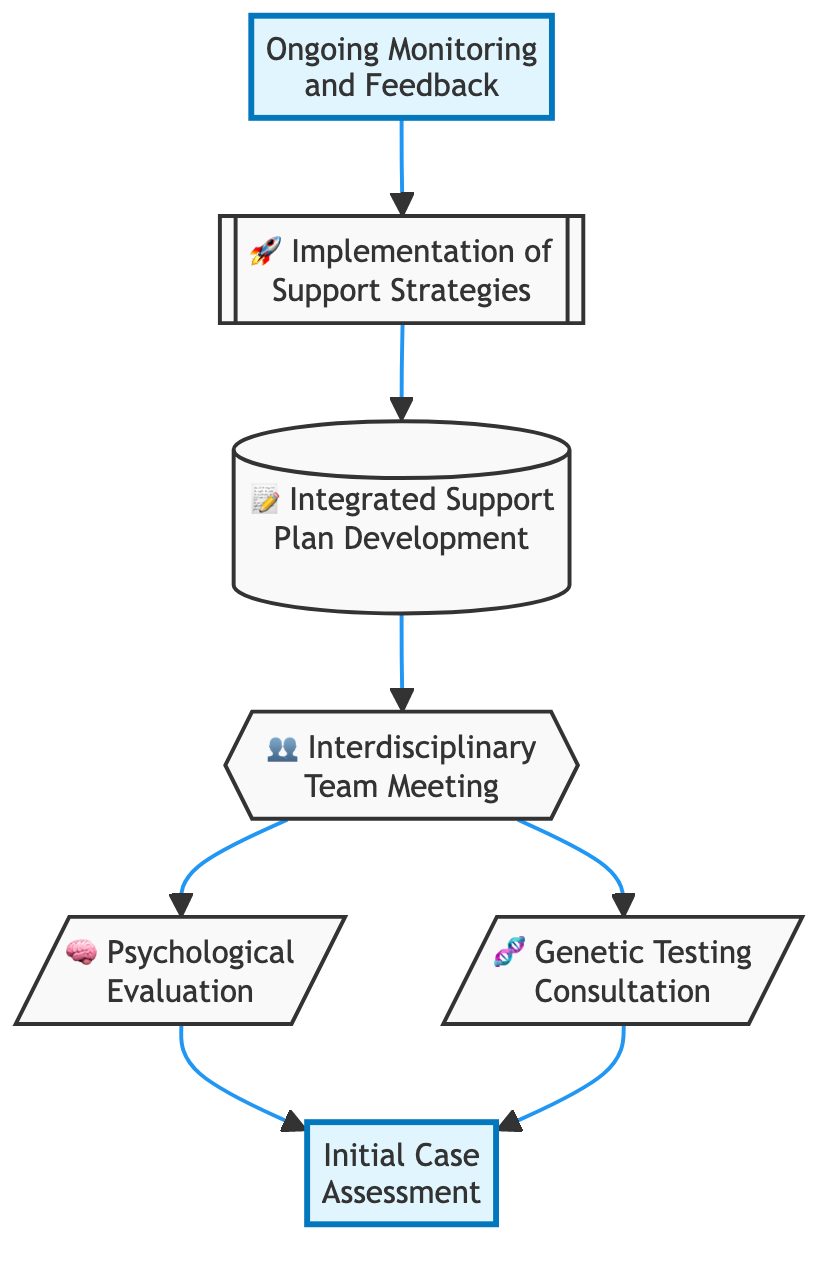What is the first step in the flow chart? The flow chart starts with the node labeled "Initial Case Assessment", which indicates it is the first step in the process of collaborative discussions between psychologists and geneticists.
Answer: Initial Case Assessment How many nodes are present in the diagram? By counting the individual elements in the flow chart, there are a total of seven nodes, each representing a different step in the collaborative framework.
Answer: 7 What is the final step in the flow chart? The last node in the diagram is titled "Ongoing Monitoring and Feedback", which concludes the series of steps outlined in the flow chart.
Answer: Ongoing Monitoring and Feedback What two assessments lead to the interdisciplinary team meeting? The processes "Psychological Evaluation" and "Genetic Testing Consultation" both direct to the "Interdisciplinary Team Meeting", indicating that insights from these assessments are shared in the meeting.
Answer: Psychological Evaluation and Genetic Testing Consultation Which step follows "Integrated Support Plan Development"? After the "Integrated Support Plan Development", the next step is "Implementation of Support Strategies", indicating that the plan is put into action after it is developed.
Answer: Implementation of Support Strategies What are the highlighted steps in the diagram? The highlighted steps in the diagram are "Initial Case Assessment" and "Ongoing Monitoring and Feedback", which have been visually emphasized for importance.
Answer: Initial Case Assessment and Ongoing Monitoring and Feedback What is the purpose of the "Interdisciplinary Team Meeting"? The purpose of the "Interdisciplinary Team Meeting" is to facilitate a gathering between psychologists and geneticists to share insights and findings from their respective assessments.
Answer: To share insights and findings from assessments Which two nodes show an outgoing flow to the same subsequent node? The nodes "Psychological Evaluation" and "Genetic Testing Consultation" both have outgoing flows leading to the same node, which is the "Interdisciplinary Team Meeting".
Answer: Psychological Evaluation and Genetic Testing Consultation 